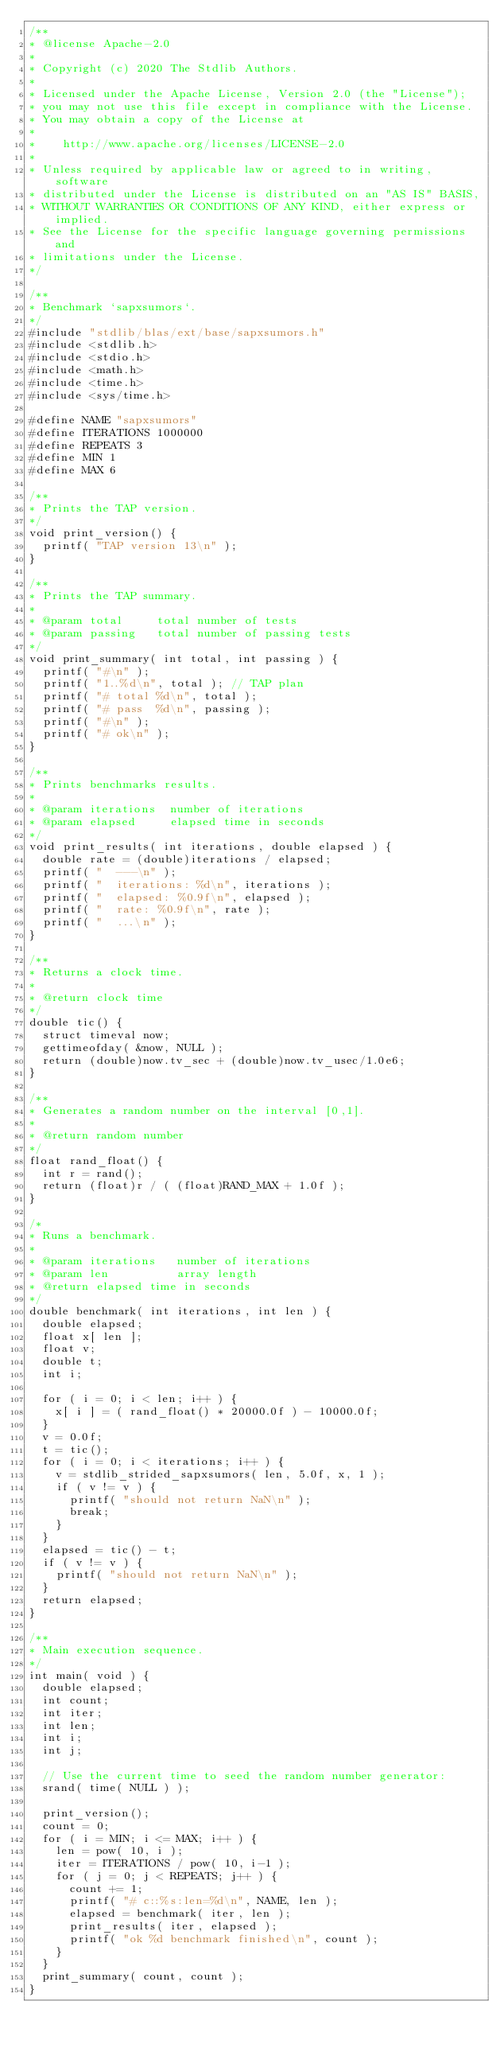<code> <loc_0><loc_0><loc_500><loc_500><_C_>/**
* @license Apache-2.0
*
* Copyright (c) 2020 The Stdlib Authors.
*
* Licensed under the Apache License, Version 2.0 (the "License");
* you may not use this file except in compliance with the License.
* You may obtain a copy of the License at
*
*    http://www.apache.org/licenses/LICENSE-2.0
*
* Unless required by applicable law or agreed to in writing, software
* distributed under the License is distributed on an "AS IS" BASIS,
* WITHOUT WARRANTIES OR CONDITIONS OF ANY KIND, either express or implied.
* See the License for the specific language governing permissions and
* limitations under the License.
*/

/**
* Benchmark `sapxsumors`.
*/
#include "stdlib/blas/ext/base/sapxsumors.h"
#include <stdlib.h>
#include <stdio.h>
#include <math.h>
#include <time.h>
#include <sys/time.h>

#define NAME "sapxsumors"
#define ITERATIONS 1000000
#define REPEATS 3
#define MIN 1
#define MAX 6

/**
* Prints the TAP version.
*/
void print_version() {
	printf( "TAP version 13\n" );
}

/**
* Prints the TAP summary.
*
* @param total     total number of tests
* @param passing   total number of passing tests
*/
void print_summary( int total, int passing ) {
	printf( "#\n" );
	printf( "1..%d\n", total ); // TAP plan
	printf( "# total %d\n", total );
	printf( "# pass  %d\n", passing );
	printf( "#\n" );
	printf( "# ok\n" );
}

/**
* Prints benchmarks results.
*
* @param iterations  number of iterations
* @param elapsed     elapsed time in seconds
*/
void print_results( int iterations, double elapsed ) {
	double rate = (double)iterations / elapsed;
	printf( "  ---\n" );
	printf( "  iterations: %d\n", iterations );
	printf( "  elapsed: %0.9f\n", elapsed );
	printf( "  rate: %0.9f\n", rate );
	printf( "  ...\n" );
}

/**
* Returns a clock time.
*
* @return clock time
*/
double tic() {
	struct timeval now;
	gettimeofday( &now, NULL );
	return (double)now.tv_sec + (double)now.tv_usec/1.0e6;
}

/**
* Generates a random number on the interval [0,1].
*
* @return random number
*/
float rand_float() {
	int r = rand();
	return (float)r / ( (float)RAND_MAX + 1.0f );
}

/*
* Runs a benchmark.
*
* @param iterations   number of iterations
* @param len          array length
* @return elapsed time in seconds
*/
double benchmark( int iterations, int len ) {
	double elapsed;
	float x[ len ];
	float v;
	double t;
	int i;

	for ( i = 0; i < len; i++ ) {
		x[ i ] = ( rand_float() * 20000.0f ) - 10000.0f;
	}
	v = 0.0f;
	t = tic();
	for ( i = 0; i < iterations; i++ ) {
		v = stdlib_strided_sapxsumors( len, 5.0f, x, 1 );
		if ( v != v ) {
			printf( "should not return NaN\n" );
			break;
		}
	}
	elapsed = tic() - t;
	if ( v != v ) {
		printf( "should not return NaN\n" );
	}
	return elapsed;
}

/**
* Main execution sequence.
*/
int main( void ) {
	double elapsed;
	int count;
	int iter;
	int len;
	int i;
	int j;

	// Use the current time to seed the random number generator:
	srand( time( NULL ) );

	print_version();
	count = 0;
	for ( i = MIN; i <= MAX; i++ ) {
		len = pow( 10, i );
		iter = ITERATIONS / pow( 10, i-1 );
		for ( j = 0; j < REPEATS; j++ ) {
			count += 1;
			printf( "# c::%s:len=%d\n", NAME, len );
			elapsed = benchmark( iter, len );
			print_results( iter, elapsed );
			printf( "ok %d benchmark finished\n", count );
		}
	}
	print_summary( count, count );
}
</code> 